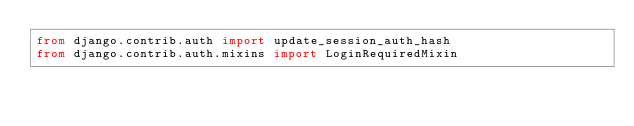Convert code to text. <code><loc_0><loc_0><loc_500><loc_500><_Python_>from django.contrib.auth import update_session_auth_hash
from django.contrib.auth.mixins import LoginRequiredMixin</code> 